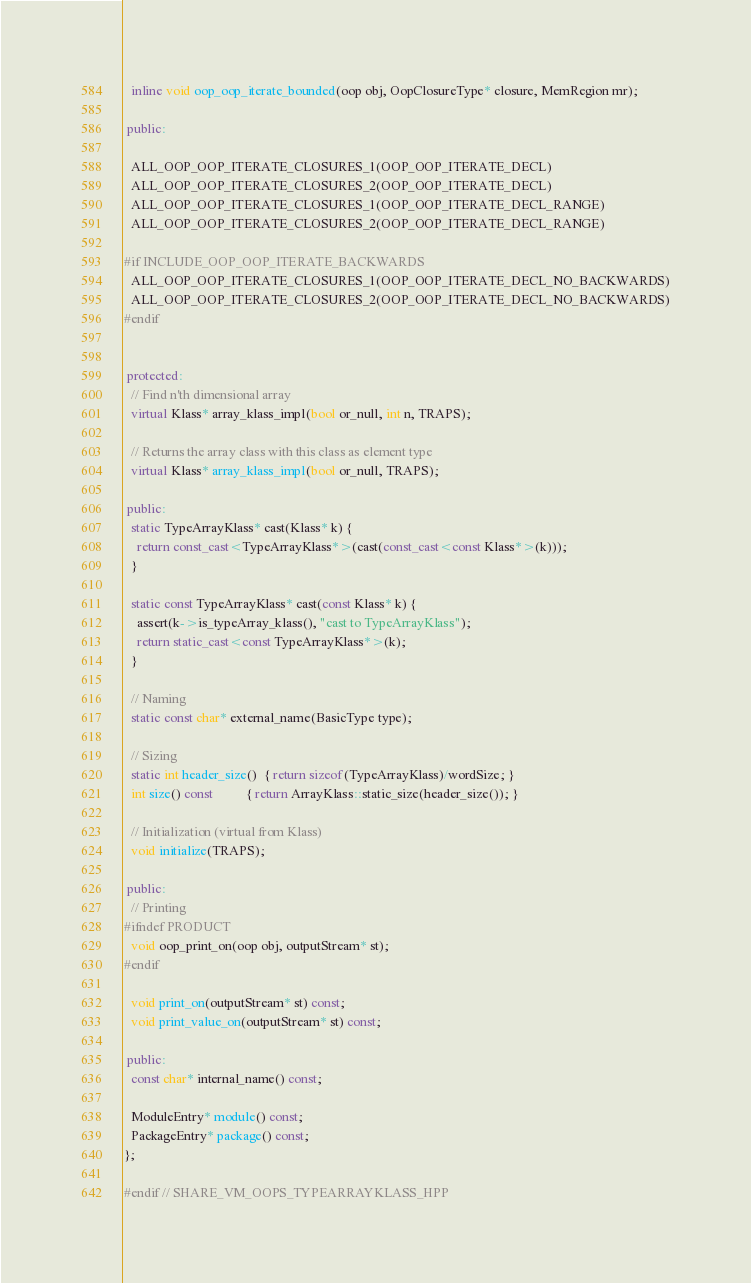Convert code to text. <code><loc_0><loc_0><loc_500><loc_500><_C++_>  inline void oop_oop_iterate_bounded(oop obj, OopClosureType* closure, MemRegion mr);

 public:

  ALL_OOP_OOP_ITERATE_CLOSURES_1(OOP_OOP_ITERATE_DECL)
  ALL_OOP_OOP_ITERATE_CLOSURES_2(OOP_OOP_ITERATE_DECL)
  ALL_OOP_OOP_ITERATE_CLOSURES_1(OOP_OOP_ITERATE_DECL_RANGE)
  ALL_OOP_OOP_ITERATE_CLOSURES_2(OOP_OOP_ITERATE_DECL_RANGE)

#if INCLUDE_OOP_OOP_ITERATE_BACKWARDS
  ALL_OOP_OOP_ITERATE_CLOSURES_1(OOP_OOP_ITERATE_DECL_NO_BACKWARDS)
  ALL_OOP_OOP_ITERATE_CLOSURES_2(OOP_OOP_ITERATE_DECL_NO_BACKWARDS)
#endif


 protected:
  // Find n'th dimensional array
  virtual Klass* array_klass_impl(bool or_null, int n, TRAPS);

  // Returns the array class with this class as element type
  virtual Klass* array_klass_impl(bool or_null, TRAPS);

 public:
  static TypeArrayKlass* cast(Klass* k) {
    return const_cast<TypeArrayKlass*>(cast(const_cast<const Klass*>(k)));
  }

  static const TypeArrayKlass* cast(const Klass* k) {
    assert(k->is_typeArray_klass(), "cast to TypeArrayKlass");
    return static_cast<const TypeArrayKlass*>(k);
  }

  // Naming
  static const char* external_name(BasicType type);

  // Sizing
  static int header_size()  { return sizeof(TypeArrayKlass)/wordSize; }
  int size() const          { return ArrayKlass::static_size(header_size()); }

  // Initialization (virtual from Klass)
  void initialize(TRAPS);

 public:
  // Printing
#ifndef PRODUCT
  void oop_print_on(oop obj, outputStream* st);
#endif

  void print_on(outputStream* st) const;
  void print_value_on(outputStream* st) const;

 public:
  const char* internal_name() const;

  ModuleEntry* module() const;
  PackageEntry* package() const;
};

#endif // SHARE_VM_OOPS_TYPEARRAYKLASS_HPP
</code> 